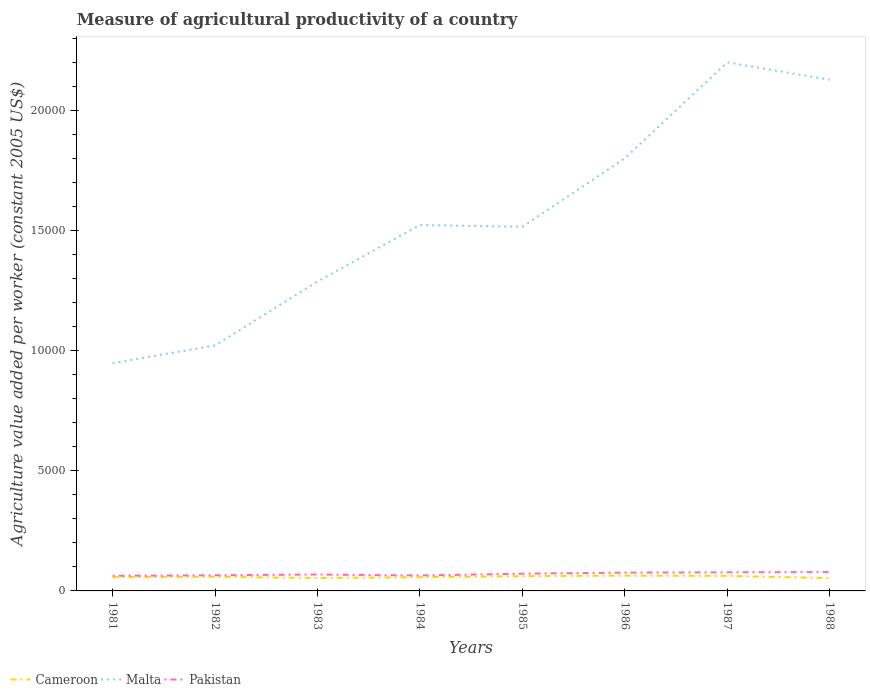How many different coloured lines are there?
Your response must be concise. 3. Across all years, what is the maximum measure of agricultural productivity in Cameroon?
Your response must be concise. 533.38. What is the total measure of agricultural productivity in Malta in the graph?
Provide a short and direct response. -3399.08. What is the difference between the highest and the second highest measure of agricultural productivity in Malta?
Offer a terse response. 1.25e+04. What is the difference between the highest and the lowest measure of agricultural productivity in Malta?
Your answer should be compact. 3. How many lines are there?
Give a very brief answer. 3. How many years are there in the graph?
Provide a succinct answer. 8. Are the values on the major ticks of Y-axis written in scientific E-notation?
Make the answer very short. No. What is the title of the graph?
Provide a succinct answer. Measure of agricultural productivity of a country. What is the label or title of the X-axis?
Provide a succinct answer. Years. What is the label or title of the Y-axis?
Your answer should be very brief. Agriculture value added per worker (constant 2005 US$). What is the Agriculture value added per worker (constant 2005 US$) in Cameroon in 1981?
Provide a succinct answer. 573.32. What is the Agriculture value added per worker (constant 2005 US$) in Malta in 1981?
Offer a very short reply. 9473.4. What is the Agriculture value added per worker (constant 2005 US$) in Pakistan in 1981?
Your answer should be compact. 629.36. What is the Agriculture value added per worker (constant 2005 US$) of Cameroon in 1982?
Your answer should be compact. 588.87. What is the Agriculture value added per worker (constant 2005 US$) of Malta in 1982?
Your response must be concise. 1.02e+04. What is the Agriculture value added per worker (constant 2005 US$) of Pakistan in 1982?
Your response must be concise. 649.18. What is the Agriculture value added per worker (constant 2005 US$) of Cameroon in 1983?
Give a very brief answer. 534.87. What is the Agriculture value added per worker (constant 2005 US$) in Malta in 1983?
Provide a short and direct response. 1.29e+04. What is the Agriculture value added per worker (constant 2005 US$) of Pakistan in 1983?
Ensure brevity in your answer.  682.93. What is the Agriculture value added per worker (constant 2005 US$) of Cameroon in 1984?
Offer a very short reply. 573.28. What is the Agriculture value added per worker (constant 2005 US$) in Malta in 1984?
Keep it short and to the point. 1.52e+04. What is the Agriculture value added per worker (constant 2005 US$) of Pakistan in 1984?
Offer a terse response. 641.81. What is the Agriculture value added per worker (constant 2005 US$) in Cameroon in 1985?
Your answer should be very brief. 613.52. What is the Agriculture value added per worker (constant 2005 US$) in Malta in 1985?
Provide a short and direct response. 1.51e+04. What is the Agriculture value added per worker (constant 2005 US$) in Pakistan in 1985?
Offer a terse response. 717.51. What is the Agriculture value added per worker (constant 2005 US$) in Cameroon in 1986?
Offer a very short reply. 636.09. What is the Agriculture value added per worker (constant 2005 US$) of Malta in 1986?
Provide a succinct answer. 1.80e+04. What is the Agriculture value added per worker (constant 2005 US$) of Pakistan in 1986?
Give a very brief answer. 761.5. What is the Agriculture value added per worker (constant 2005 US$) in Cameroon in 1987?
Your response must be concise. 624.71. What is the Agriculture value added per worker (constant 2005 US$) of Malta in 1987?
Keep it short and to the point. 2.20e+04. What is the Agriculture value added per worker (constant 2005 US$) in Pakistan in 1987?
Give a very brief answer. 773.63. What is the Agriculture value added per worker (constant 2005 US$) in Cameroon in 1988?
Give a very brief answer. 533.38. What is the Agriculture value added per worker (constant 2005 US$) in Malta in 1988?
Provide a short and direct response. 2.13e+04. What is the Agriculture value added per worker (constant 2005 US$) of Pakistan in 1988?
Your answer should be very brief. 782.91. Across all years, what is the maximum Agriculture value added per worker (constant 2005 US$) in Cameroon?
Give a very brief answer. 636.09. Across all years, what is the maximum Agriculture value added per worker (constant 2005 US$) in Malta?
Your response must be concise. 2.20e+04. Across all years, what is the maximum Agriculture value added per worker (constant 2005 US$) of Pakistan?
Ensure brevity in your answer.  782.91. Across all years, what is the minimum Agriculture value added per worker (constant 2005 US$) of Cameroon?
Give a very brief answer. 533.38. Across all years, what is the minimum Agriculture value added per worker (constant 2005 US$) of Malta?
Provide a short and direct response. 9473.4. Across all years, what is the minimum Agriculture value added per worker (constant 2005 US$) of Pakistan?
Your answer should be very brief. 629.36. What is the total Agriculture value added per worker (constant 2005 US$) in Cameroon in the graph?
Offer a terse response. 4678.05. What is the total Agriculture value added per worker (constant 2005 US$) of Malta in the graph?
Offer a terse response. 1.24e+05. What is the total Agriculture value added per worker (constant 2005 US$) in Pakistan in the graph?
Give a very brief answer. 5638.83. What is the difference between the Agriculture value added per worker (constant 2005 US$) of Cameroon in 1981 and that in 1982?
Keep it short and to the point. -15.55. What is the difference between the Agriculture value added per worker (constant 2005 US$) of Malta in 1981 and that in 1982?
Your answer should be compact. -737.77. What is the difference between the Agriculture value added per worker (constant 2005 US$) of Pakistan in 1981 and that in 1982?
Make the answer very short. -19.82. What is the difference between the Agriculture value added per worker (constant 2005 US$) in Cameroon in 1981 and that in 1983?
Ensure brevity in your answer.  38.45. What is the difference between the Agriculture value added per worker (constant 2005 US$) in Malta in 1981 and that in 1983?
Keep it short and to the point. -3399.08. What is the difference between the Agriculture value added per worker (constant 2005 US$) of Pakistan in 1981 and that in 1983?
Your answer should be very brief. -53.57. What is the difference between the Agriculture value added per worker (constant 2005 US$) in Cameroon in 1981 and that in 1984?
Give a very brief answer. 0.03. What is the difference between the Agriculture value added per worker (constant 2005 US$) in Malta in 1981 and that in 1984?
Provide a short and direct response. -5747.92. What is the difference between the Agriculture value added per worker (constant 2005 US$) in Pakistan in 1981 and that in 1984?
Keep it short and to the point. -12.45. What is the difference between the Agriculture value added per worker (constant 2005 US$) in Cameroon in 1981 and that in 1985?
Provide a short and direct response. -40.21. What is the difference between the Agriculture value added per worker (constant 2005 US$) in Malta in 1981 and that in 1985?
Make the answer very short. -5674.32. What is the difference between the Agriculture value added per worker (constant 2005 US$) in Pakistan in 1981 and that in 1985?
Offer a very short reply. -88.15. What is the difference between the Agriculture value added per worker (constant 2005 US$) in Cameroon in 1981 and that in 1986?
Give a very brief answer. -62.77. What is the difference between the Agriculture value added per worker (constant 2005 US$) in Malta in 1981 and that in 1986?
Make the answer very short. -8518.3. What is the difference between the Agriculture value added per worker (constant 2005 US$) in Pakistan in 1981 and that in 1986?
Ensure brevity in your answer.  -132.15. What is the difference between the Agriculture value added per worker (constant 2005 US$) of Cameroon in 1981 and that in 1987?
Your answer should be very brief. -51.39. What is the difference between the Agriculture value added per worker (constant 2005 US$) in Malta in 1981 and that in 1987?
Make the answer very short. -1.25e+04. What is the difference between the Agriculture value added per worker (constant 2005 US$) of Pakistan in 1981 and that in 1987?
Offer a terse response. -144.28. What is the difference between the Agriculture value added per worker (constant 2005 US$) in Cameroon in 1981 and that in 1988?
Your answer should be very brief. 39.94. What is the difference between the Agriculture value added per worker (constant 2005 US$) of Malta in 1981 and that in 1988?
Provide a succinct answer. -1.18e+04. What is the difference between the Agriculture value added per worker (constant 2005 US$) in Pakistan in 1981 and that in 1988?
Your answer should be compact. -153.56. What is the difference between the Agriculture value added per worker (constant 2005 US$) of Cameroon in 1982 and that in 1983?
Give a very brief answer. 54.01. What is the difference between the Agriculture value added per worker (constant 2005 US$) in Malta in 1982 and that in 1983?
Your answer should be very brief. -2661.31. What is the difference between the Agriculture value added per worker (constant 2005 US$) of Pakistan in 1982 and that in 1983?
Your answer should be very brief. -33.75. What is the difference between the Agriculture value added per worker (constant 2005 US$) in Cameroon in 1982 and that in 1984?
Keep it short and to the point. 15.59. What is the difference between the Agriculture value added per worker (constant 2005 US$) in Malta in 1982 and that in 1984?
Offer a very short reply. -5010.15. What is the difference between the Agriculture value added per worker (constant 2005 US$) in Pakistan in 1982 and that in 1984?
Your answer should be compact. 7.37. What is the difference between the Agriculture value added per worker (constant 2005 US$) of Cameroon in 1982 and that in 1985?
Your answer should be compact. -24.65. What is the difference between the Agriculture value added per worker (constant 2005 US$) in Malta in 1982 and that in 1985?
Offer a terse response. -4936.55. What is the difference between the Agriculture value added per worker (constant 2005 US$) in Pakistan in 1982 and that in 1985?
Give a very brief answer. -68.33. What is the difference between the Agriculture value added per worker (constant 2005 US$) in Cameroon in 1982 and that in 1986?
Your answer should be very brief. -47.22. What is the difference between the Agriculture value added per worker (constant 2005 US$) in Malta in 1982 and that in 1986?
Provide a short and direct response. -7780.53. What is the difference between the Agriculture value added per worker (constant 2005 US$) of Pakistan in 1982 and that in 1986?
Ensure brevity in your answer.  -112.33. What is the difference between the Agriculture value added per worker (constant 2005 US$) in Cameroon in 1982 and that in 1987?
Give a very brief answer. -35.83. What is the difference between the Agriculture value added per worker (constant 2005 US$) of Malta in 1982 and that in 1987?
Give a very brief answer. -1.18e+04. What is the difference between the Agriculture value added per worker (constant 2005 US$) in Pakistan in 1982 and that in 1987?
Make the answer very short. -124.46. What is the difference between the Agriculture value added per worker (constant 2005 US$) in Cameroon in 1982 and that in 1988?
Offer a terse response. 55.49. What is the difference between the Agriculture value added per worker (constant 2005 US$) in Malta in 1982 and that in 1988?
Keep it short and to the point. -1.11e+04. What is the difference between the Agriculture value added per worker (constant 2005 US$) of Pakistan in 1982 and that in 1988?
Provide a short and direct response. -133.74. What is the difference between the Agriculture value added per worker (constant 2005 US$) of Cameroon in 1983 and that in 1984?
Provide a succinct answer. -38.42. What is the difference between the Agriculture value added per worker (constant 2005 US$) of Malta in 1983 and that in 1984?
Keep it short and to the point. -2348.84. What is the difference between the Agriculture value added per worker (constant 2005 US$) in Pakistan in 1983 and that in 1984?
Ensure brevity in your answer.  41.12. What is the difference between the Agriculture value added per worker (constant 2005 US$) of Cameroon in 1983 and that in 1985?
Give a very brief answer. -78.66. What is the difference between the Agriculture value added per worker (constant 2005 US$) of Malta in 1983 and that in 1985?
Provide a succinct answer. -2275.24. What is the difference between the Agriculture value added per worker (constant 2005 US$) in Pakistan in 1983 and that in 1985?
Keep it short and to the point. -34.58. What is the difference between the Agriculture value added per worker (constant 2005 US$) in Cameroon in 1983 and that in 1986?
Your answer should be very brief. -101.22. What is the difference between the Agriculture value added per worker (constant 2005 US$) of Malta in 1983 and that in 1986?
Your answer should be very brief. -5119.22. What is the difference between the Agriculture value added per worker (constant 2005 US$) of Pakistan in 1983 and that in 1986?
Ensure brevity in your answer.  -78.58. What is the difference between the Agriculture value added per worker (constant 2005 US$) in Cameroon in 1983 and that in 1987?
Provide a short and direct response. -89.84. What is the difference between the Agriculture value added per worker (constant 2005 US$) of Malta in 1983 and that in 1987?
Offer a very short reply. -9114.55. What is the difference between the Agriculture value added per worker (constant 2005 US$) of Pakistan in 1983 and that in 1987?
Give a very brief answer. -90.71. What is the difference between the Agriculture value added per worker (constant 2005 US$) in Cameroon in 1983 and that in 1988?
Give a very brief answer. 1.48. What is the difference between the Agriculture value added per worker (constant 2005 US$) of Malta in 1983 and that in 1988?
Keep it short and to the point. -8389.81. What is the difference between the Agriculture value added per worker (constant 2005 US$) in Pakistan in 1983 and that in 1988?
Provide a succinct answer. -99.99. What is the difference between the Agriculture value added per worker (constant 2005 US$) in Cameroon in 1984 and that in 1985?
Provide a short and direct response. -40.24. What is the difference between the Agriculture value added per worker (constant 2005 US$) of Malta in 1984 and that in 1985?
Your answer should be very brief. 73.6. What is the difference between the Agriculture value added per worker (constant 2005 US$) in Pakistan in 1984 and that in 1985?
Give a very brief answer. -75.7. What is the difference between the Agriculture value added per worker (constant 2005 US$) of Cameroon in 1984 and that in 1986?
Offer a terse response. -62.81. What is the difference between the Agriculture value added per worker (constant 2005 US$) of Malta in 1984 and that in 1986?
Offer a very short reply. -2770.38. What is the difference between the Agriculture value added per worker (constant 2005 US$) in Pakistan in 1984 and that in 1986?
Provide a succinct answer. -119.69. What is the difference between the Agriculture value added per worker (constant 2005 US$) of Cameroon in 1984 and that in 1987?
Make the answer very short. -51.42. What is the difference between the Agriculture value added per worker (constant 2005 US$) of Malta in 1984 and that in 1987?
Provide a short and direct response. -6765.71. What is the difference between the Agriculture value added per worker (constant 2005 US$) in Pakistan in 1984 and that in 1987?
Your response must be concise. -131.82. What is the difference between the Agriculture value added per worker (constant 2005 US$) of Cameroon in 1984 and that in 1988?
Provide a succinct answer. 39.9. What is the difference between the Agriculture value added per worker (constant 2005 US$) in Malta in 1984 and that in 1988?
Make the answer very short. -6040.97. What is the difference between the Agriculture value added per worker (constant 2005 US$) in Pakistan in 1984 and that in 1988?
Keep it short and to the point. -141.11. What is the difference between the Agriculture value added per worker (constant 2005 US$) of Cameroon in 1985 and that in 1986?
Give a very brief answer. -22.57. What is the difference between the Agriculture value added per worker (constant 2005 US$) in Malta in 1985 and that in 1986?
Provide a short and direct response. -2843.98. What is the difference between the Agriculture value added per worker (constant 2005 US$) in Pakistan in 1985 and that in 1986?
Provide a short and direct response. -43.99. What is the difference between the Agriculture value added per worker (constant 2005 US$) of Cameroon in 1985 and that in 1987?
Keep it short and to the point. -11.18. What is the difference between the Agriculture value added per worker (constant 2005 US$) in Malta in 1985 and that in 1987?
Provide a succinct answer. -6839.31. What is the difference between the Agriculture value added per worker (constant 2005 US$) in Pakistan in 1985 and that in 1987?
Your answer should be compact. -56.12. What is the difference between the Agriculture value added per worker (constant 2005 US$) of Cameroon in 1985 and that in 1988?
Your response must be concise. 80.14. What is the difference between the Agriculture value added per worker (constant 2005 US$) of Malta in 1985 and that in 1988?
Your answer should be compact. -6114.57. What is the difference between the Agriculture value added per worker (constant 2005 US$) in Pakistan in 1985 and that in 1988?
Give a very brief answer. -65.4. What is the difference between the Agriculture value added per worker (constant 2005 US$) of Cameroon in 1986 and that in 1987?
Offer a terse response. 11.38. What is the difference between the Agriculture value added per worker (constant 2005 US$) of Malta in 1986 and that in 1987?
Offer a terse response. -3995.34. What is the difference between the Agriculture value added per worker (constant 2005 US$) in Pakistan in 1986 and that in 1987?
Your answer should be compact. -12.13. What is the difference between the Agriculture value added per worker (constant 2005 US$) of Cameroon in 1986 and that in 1988?
Offer a terse response. 102.71. What is the difference between the Agriculture value added per worker (constant 2005 US$) of Malta in 1986 and that in 1988?
Make the answer very short. -3270.59. What is the difference between the Agriculture value added per worker (constant 2005 US$) of Pakistan in 1986 and that in 1988?
Offer a terse response. -21.41. What is the difference between the Agriculture value added per worker (constant 2005 US$) in Cameroon in 1987 and that in 1988?
Ensure brevity in your answer.  91.32. What is the difference between the Agriculture value added per worker (constant 2005 US$) of Malta in 1987 and that in 1988?
Provide a short and direct response. 724.74. What is the difference between the Agriculture value added per worker (constant 2005 US$) of Pakistan in 1987 and that in 1988?
Give a very brief answer. -9.28. What is the difference between the Agriculture value added per worker (constant 2005 US$) in Cameroon in 1981 and the Agriculture value added per worker (constant 2005 US$) in Malta in 1982?
Make the answer very short. -9637.85. What is the difference between the Agriculture value added per worker (constant 2005 US$) in Cameroon in 1981 and the Agriculture value added per worker (constant 2005 US$) in Pakistan in 1982?
Provide a succinct answer. -75.86. What is the difference between the Agriculture value added per worker (constant 2005 US$) of Malta in 1981 and the Agriculture value added per worker (constant 2005 US$) of Pakistan in 1982?
Your response must be concise. 8824.22. What is the difference between the Agriculture value added per worker (constant 2005 US$) in Cameroon in 1981 and the Agriculture value added per worker (constant 2005 US$) in Malta in 1983?
Make the answer very short. -1.23e+04. What is the difference between the Agriculture value added per worker (constant 2005 US$) of Cameroon in 1981 and the Agriculture value added per worker (constant 2005 US$) of Pakistan in 1983?
Your answer should be compact. -109.61. What is the difference between the Agriculture value added per worker (constant 2005 US$) of Malta in 1981 and the Agriculture value added per worker (constant 2005 US$) of Pakistan in 1983?
Ensure brevity in your answer.  8790.47. What is the difference between the Agriculture value added per worker (constant 2005 US$) in Cameroon in 1981 and the Agriculture value added per worker (constant 2005 US$) in Malta in 1984?
Provide a succinct answer. -1.46e+04. What is the difference between the Agriculture value added per worker (constant 2005 US$) in Cameroon in 1981 and the Agriculture value added per worker (constant 2005 US$) in Pakistan in 1984?
Make the answer very short. -68.49. What is the difference between the Agriculture value added per worker (constant 2005 US$) in Malta in 1981 and the Agriculture value added per worker (constant 2005 US$) in Pakistan in 1984?
Offer a terse response. 8831.59. What is the difference between the Agriculture value added per worker (constant 2005 US$) in Cameroon in 1981 and the Agriculture value added per worker (constant 2005 US$) in Malta in 1985?
Keep it short and to the point. -1.46e+04. What is the difference between the Agriculture value added per worker (constant 2005 US$) of Cameroon in 1981 and the Agriculture value added per worker (constant 2005 US$) of Pakistan in 1985?
Keep it short and to the point. -144.19. What is the difference between the Agriculture value added per worker (constant 2005 US$) of Malta in 1981 and the Agriculture value added per worker (constant 2005 US$) of Pakistan in 1985?
Give a very brief answer. 8755.89. What is the difference between the Agriculture value added per worker (constant 2005 US$) of Cameroon in 1981 and the Agriculture value added per worker (constant 2005 US$) of Malta in 1986?
Offer a very short reply. -1.74e+04. What is the difference between the Agriculture value added per worker (constant 2005 US$) of Cameroon in 1981 and the Agriculture value added per worker (constant 2005 US$) of Pakistan in 1986?
Your response must be concise. -188.18. What is the difference between the Agriculture value added per worker (constant 2005 US$) of Malta in 1981 and the Agriculture value added per worker (constant 2005 US$) of Pakistan in 1986?
Your answer should be very brief. 8711.89. What is the difference between the Agriculture value added per worker (constant 2005 US$) of Cameroon in 1981 and the Agriculture value added per worker (constant 2005 US$) of Malta in 1987?
Your response must be concise. -2.14e+04. What is the difference between the Agriculture value added per worker (constant 2005 US$) in Cameroon in 1981 and the Agriculture value added per worker (constant 2005 US$) in Pakistan in 1987?
Your answer should be very brief. -200.31. What is the difference between the Agriculture value added per worker (constant 2005 US$) in Malta in 1981 and the Agriculture value added per worker (constant 2005 US$) in Pakistan in 1987?
Offer a very short reply. 8699.77. What is the difference between the Agriculture value added per worker (constant 2005 US$) of Cameroon in 1981 and the Agriculture value added per worker (constant 2005 US$) of Malta in 1988?
Provide a succinct answer. -2.07e+04. What is the difference between the Agriculture value added per worker (constant 2005 US$) in Cameroon in 1981 and the Agriculture value added per worker (constant 2005 US$) in Pakistan in 1988?
Keep it short and to the point. -209.59. What is the difference between the Agriculture value added per worker (constant 2005 US$) in Malta in 1981 and the Agriculture value added per worker (constant 2005 US$) in Pakistan in 1988?
Make the answer very short. 8690.48. What is the difference between the Agriculture value added per worker (constant 2005 US$) of Cameroon in 1982 and the Agriculture value added per worker (constant 2005 US$) of Malta in 1983?
Your response must be concise. -1.23e+04. What is the difference between the Agriculture value added per worker (constant 2005 US$) in Cameroon in 1982 and the Agriculture value added per worker (constant 2005 US$) in Pakistan in 1983?
Ensure brevity in your answer.  -94.05. What is the difference between the Agriculture value added per worker (constant 2005 US$) of Malta in 1982 and the Agriculture value added per worker (constant 2005 US$) of Pakistan in 1983?
Offer a terse response. 9528.24. What is the difference between the Agriculture value added per worker (constant 2005 US$) of Cameroon in 1982 and the Agriculture value added per worker (constant 2005 US$) of Malta in 1984?
Offer a very short reply. -1.46e+04. What is the difference between the Agriculture value added per worker (constant 2005 US$) of Cameroon in 1982 and the Agriculture value added per worker (constant 2005 US$) of Pakistan in 1984?
Ensure brevity in your answer.  -52.94. What is the difference between the Agriculture value added per worker (constant 2005 US$) of Malta in 1982 and the Agriculture value added per worker (constant 2005 US$) of Pakistan in 1984?
Provide a succinct answer. 9569.36. What is the difference between the Agriculture value added per worker (constant 2005 US$) in Cameroon in 1982 and the Agriculture value added per worker (constant 2005 US$) in Malta in 1985?
Give a very brief answer. -1.46e+04. What is the difference between the Agriculture value added per worker (constant 2005 US$) of Cameroon in 1982 and the Agriculture value added per worker (constant 2005 US$) of Pakistan in 1985?
Offer a terse response. -128.64. What is the difference between the Agriculture value added per worker (constant 2005 US$) of Malta in 1982 and the Agriculture value added per worker (constant 2005 US$) of Pakistan in 1985?
Your answer should be compact. 9493.66. What is the difference between the Agriculture value added per worker (constant 2005 US$) of Cameroon in 1982 and the Agriculture value added per worker (constant 2005 US$) of Malta in 1986?
Keep it short and to the point. -1.74e+04. What is the difference between the Agriculture value added per worker (constant 2005 US$) in Cameroon in 1982 and the Agriculture value added per worker (constant 2005 US$) in Pakistan in 1986?
Your response must be concise. -172.63. What is the difference between the Agriculture value added per worker (constant 2005 US$) in Malta in 1982 and the Agriculture value added per worker (constant 2005 US$) in Pakistan in 1986?
Give a very brief answer. 9449.66. What is the difference between the Agriculture value added per worker (constant 2005 US$) of Cameroon in 1982 and the Agriculture value added per worker (constant 2005 US$) of Malta in 1987?
Your answer should be compact. -2.14e+04. What is the difference between the Agriculture value added per worker (constant 2005 US$) in Cameroon in 1982 and the Agriculture value added per worker (constant 2005 US$) in Pakistan in 1987?
Offer a terse response. -184.76. What is the difference between the Agriculture value added per worker (constant 2005 US$) of Malta in 1982 and the Agriculture value added per worker (constant 2005 US$) of Pakistan in 1987?
Offer a terse response. 9437.53. What is the difference between the Agriculture value added per worker (constant 2005 US$) in Cameroon in 1982 and the Agriculture value added per worker (constant 2005 US$) in Malta in 1988?
Ensure brevity in your answer.  -2.07e+04. What is the difference between the Agriculture value added per worker (constant 2005 US$) in Cameroon in 1982 and the Agriculture value added per worker (constant 2005 US$) in Pakistan in 1988?
Offer a terse response. -194.04. What is the difference between the Agriculture value added per worker (constant 2005 US$) of Malta in 1982 and the Agriculture value added per worker (constant 2005 US$) of Pakistan in 1988?
Provide a short and direct response. 9428.25. What is the difference between the Agriculture value added per worker (constant 2005 US$) of Cameroon in 1983 and the Agriculture value added per worker (constant 2005 US$) of Malta in 1984?
Make the answer very short. -1.47e+04. What is the difference between the Agriculture value added per worker (constant 2005 US$) in Cameroon in 1983 and the Agriculture value added per worker (constant 2005 US$) in Pakistan in 1984?
Provide a short and direct response. -106.94. What is the difference between the Agriculture value added per worker (constant 2005 US$) of Malta in 1983 and the Agriculture value added per worker (constant 2005 US$) of Pakistan in 1984?
Your response must be concise. 1.22e+04. What is the difference between the Agriculture value added per worker (constant 2005 US$) of Cameroon in 1983 and the Agriculture value added per worker (constant 2005 US$) of Malta in 1985?
Make the answer very short. -1.46e+04. What is the difference between the Agriculture value added per worker (constant 2005 US$) of Cameroon in 1983 and the Agriculture value added per worker (constant 2005 US$) of Pakistan in 1985?
Provide a short and direct response. -182.64. What is the difference between the Agriculture value added per worker (constant 2005 US$) in Malta in 1983 and the Agriculture value added per worker (constant 2005 US$) in Pakistan in 1985?
Make the answer very short. 1.22e+04. What is the difference between the Agriculture value added per worker (constant 2005 US$) of Cameroon in 1983 and the Agriculture value added per worker (constant 2005 US$) of Malta in 1986?
Your response must be concise. -1.75e+04. What is the difference between the Agriculture value added per worker (constant 2005 US$) in Cameroon in 1983 and the Agriculture value added per worker (constant 2005 US$) in Pakistan in 1986?
Make the answer very short. -226.64. What is the difference between the Agriculture value added per worker (constant 2005 US$) in Malta in 1983 and the Agriculture value added per worker (constant 2005 US$) in Pakistan in 1986?
Offer a very short reply. 1.21e+04. What is the difference between the Agriculture value added per worker (constant 2005 US$) in Cameroon in 1983 and the Agriculture value added per worker (constant 2005 US$) in Malta in 1987?
Offer a very short reply. -2.15e+04. What is the difference between the Agriculture value added per worker (constant 2005 US$) of Cameroon in 1983 and the Agriculture value added per worker (constant 2005 US$) of Pakistan in 1987?
Offer a very short reply. -238.77. What is the difference between the Agriculture value added per worker (constant 2005 US$) of Malta in 1983 and the Agriculture value added per worker (constant 2005 US$) of Pakistan in 1987?
Make the answer very short. 1.21e+04. What is the difference between the Agriculture value added per worker (constant 2005 US$) of Cameroon in 1983 and the Agriculture value added per worker (constant 2005 US$) of Malta in 1988?
Your response must be concise. -2.07e+04. What is the difference between the Agriculture value added per worker (constant 2005 US$) of Cameroon in 1983 and the Agriculture value added per worker (constant 2005 US$) of Pakistan in 1988?
Offer a very short reply. -248.05. What is the difference between the Agriculture value added per worker (constant 2005 US$) of Malta in 1983 and the Agriculture value added per worker (constant 2005 US$) of Pakistan in 1988?
Make the answer very short. 1.21e+04. What is the difference between the Agriculture value added per worker (constant 2005 US$) of Cameroon in 1984 and the Agriculture value added per worker (constant 2005 US$) of Malta in 1985?
Make the answer very short. -1.46e+04. What is the difference between the Agriculture value added per worker (constant 2005 US$) of Cameroon in 1984 and the Agriculture value added per worker (constant 2005 US$) of Pakistan in 1985?
Offer a very short reply. -144.23. What is the difference between the Agriculture value added per worker (constant 2005 US$) in Malta in 1984 and the Agriculture value added per worker (constant 2005 US$) in Pakistan in 1985?
Offer a very short reply. 1.45e+04. What is the difference between the Agriculture value added per worker (constant 2005 US$) of Cameroon in 1984 and the Agriculture value added per worker (constant 2005 US$) of Malta in 1986?
Keep it short and to the point. -1.74e+04. What is the difference between the Agriculture value added per worker (constant 2005 US$) of Cameroon in 1984 and the Agriculture value added per worker (constant 2005 US$) of Pakistan in 1986?
Your response must be concise. -188.22. What is the difference between the Agriculture value added per worker (constant 2005 US$) in Malta in 1984 and the Agriculture value added per worker (constant 2005 US$) in Pakistan in 1986?
Keep it short and to the point. 1.45e+04. What is the difference between the Agriculture value added per worker (constant 2005 US$) of Cameroon in 1984 and the Agriculture value added per worker (constant 2005 US$) of Malta in 1987?
Your response must be concise. -2.14e+04. What is the difference between the Agriculture value added per worker (constant 2005 US$) in Cameroon in 1984 and the Agriculture value added per worker (constant 2005 US$) in Pakistan in 1987?
Give a very brief answer. -200.35. What is the difference between the Agriculture value added per worker (constant 2005 US$) of Malta in 1984 and the Agriculture value added per worker (constant 2005 US$) of Pakistan in 1987?
Your response must be concise. 1.44e+04. What is the difference between the Agriculture value added per worker (constant 2005 US$) in Cameroon in 1984 and the Agriculture value added per worker (constant 2005 US$) in Malta in 1988?
Give a very brief answer. -2.07e+04. What is the difference between the Agriculture value added per worker (constant 2005 US$) in Cameroon in 1984 and the Agriculture value added per worker (constant 2005 US$) in Pakistan in 1988?
Provide a short and direct response. -209.63. What is the difference between the Agriculture value added per worker (constant 2005 US$) of Malta in 1984 and the Agriculture value added per worker (constant 2005 US$) of Pakistan in 1988?
Make the answer very short. 1.44e+04. What is the difference between the Agriculture value added per worker (constant 2005 US$) in Cameroon in 1985 and the Agriculture value added per worker (constant 2005 US$) in Malta in 1986?
Your answer should be very brief. -1.74e+04. What is the difference between the Agriculture value added per worker (constant 2005 US$) in Cameroon in 1985 and the Agriculture value added per worker (constant 2005 US$) in Pakistan in 1986?
Give a very brief answer. -147.98. What is the difference between the Agriculture value added per worker (constant 2005 US$) in Malta in 1985 and the Agriculture value added per worker (constant 2005 US$) in Pakistan in 1986?
Offer a terse response. 1.44e+04. What is the difference between the Agriculture value added per worker (constant 2005 US$) of Cameroon in 1985 and the Agriculture value added per worker (constant 2005 US$) of Malta in 1987?
Your answer should be very brief. -2.14e+04. What is the difference between the Agriculture value added per worker (constant 2005 US$) of Cameroon in 1985 and the Agriculture value added per worker (constant 2005 US$) of Pakistan in 1987?
Ensure brevity in your answer.  -160.11. What is the difference between the Agriculture value added per worker (constant 2005 US$) in Malta in 1985 and the Agriculture value added per worker (constant 2005 US$) in Pakistan in 1987?
Make the answer very short. 1.44e+04. What is the difference between the Agriculture value added per worker (constant 2005 US$) of Cameroon in 1985 and the Agriculture value added per worker (constant 2005 US$) of Malta in 1988?
Your answer should be compact. -2.06e+04. What is the difference between the Agriculture value added per worker (constant 2005 US$) of Cameroon in 1985 and the Agriculture value added per worker (constant 2005 US$) of Pakistan in 1988?
Your response must be concise. -169.39. What is the difference between the Agriculture value added per worker (constant 2005 US$) of Malta in 1985 and the Agriculture value added per worker (constant 2005 US$) of Pakistan in 1988?
Your answer should be very brief. 1.44e+04. What is the difference between the Agriculture value added per worker (constant 2005 US$) in Cameroon in 1986 and the Agriculture value added per worker (constant 2005 US$) in Malta in 1987?
Your answer should be very brief. -2.14e+04. What is the difference between the Agriculture value added per worker (constant 2005 US$) in Cameroon in 1986 and the Agriculture value added per worker (constant 2005 US$) in Pakistan in 1987?
Ensure brevity in your answer.  -137.54. What is the difference between the Agriculture value added per worker (constant 2005 US$) of Malta in 1986 and the Agriculture value added per worker (constant 2005 US$) of Pakistan in 1987?
Your answer should be very brief. 1.72e+04. What is the difference between the Agriculture value added per worker (constant 2005 US$) of Cameroon in 1986 and the Agriculture value added per worker (constant 2005 US$) of Malta in 1988?
Give a very brief answer. -2.06e+04. What is the difference between the Agriculture value added per worker (constant 2005 US$) in Cameroon in 1986 and the Agriculture value added per worker (constant 2005 US$) in Pakistan in 1988?
Give a very brief answer. -146.82. What is the difference between the Agriculture value added per worker (constant 2005 US$) in Malta in 1986 and the Agriculture value added per worker (constant 2005 US$) in Pakistan in 1988?
Ensure brevity in your answer.  1.72e+04. What is the difference between the Agriculture value added per worker (constant 2005 US$) of Cameroon in 1987 and the Agriculture value added per worker (constant 2005 US$) of Malta in 1988?
Ensure brevity in your answer.  -2.06e+04. What is the difference between the Agriculture value added per worker (constant 2005 US$) in Cameroon in 1987 and the Agriculture value added per worker (constant 2005 US$) in Pakistan in 1988?
Keep it short and to the point. -158.21. What is the difference between the Agriculture value added per worker (constant 2005 US$) of Malta in 1987 and the Agriculture value added per worker (constant 2005 US$) of Pakistan in 1988?
Offer a very short reply. 2.12e+04. What is the average Agriculture value added per worker (constant 2005 US$) of Cameroon per year?
Give a very brief answer. 584.76. What is the average Agriculture value added per worker (constant 2005 US$) in Malta per year?
Offer a terse response. 1.55e+04. What is the average Agriculture value added per worker (constant 2005 US$) in Pakistan per year?
Ensure brevity in your answer.  704.85. In the year 1981, what is the difference between the Agriculture value added per worker (constant 2005 US$) in Cameroon and Agriculture value added per worker (constant 2005 US$) in Malta?
Give a very brief answer. -8900.08. In the year 1981, what is the difference between the Agriculture value added per worker (constant 2005 US$) of Cameroon and Agriculture value added per worker (constant 2005 US$) of Pakistan?
Ensure brevity in your answer.  -56.04. In the year 1981, what is the difference between the Agriculture value added per worker (constant 2005 US$) in Malta and Agriculture value added per worker (constant 2005 US$) in Pakistan?
Ensure brevity in your answer.  8844.04. In the year 1982, what is the difference between the Agriculture value added per worker (constant 2005 US$) in Cameroon and Agriculture value added per worker (constant 2005 US$) in Malta?
Offer a very short reply. -9622.29. In the year 1982, what is the difference between the Agriculture value added per worker (constant 2005 US$) of Cameroon and Agriculture value added per worker (constant 2005 US$) of Pakistan?
Make the answer very short. -60.3. In the year 1982, what is the difference between the Agriculture value added per worker (constant 2005 US$) of Malta and Agriculture value added per worker (constant 2005 US$) of Pakistan?
Your answer should be compact. 9561.99. In the year 1983, what is the difference between the Agriculture value added per worker (constant 2005 US$) of Cameroon and Agriculture value added per worker (constant 2005 US$) of Malta?
Make the answer very short. -1.23e+04. In the year 1983, what is the difference between the Agriculture value added per worker (constant 2005 US$) of Cameroon and Agriculture value added per worker (constant 2005 US$) of Pakistan?
Your answer should be compact. -148.06. In the year 1983, what is the difference between the Agriculture value added per worker (constant 2005 US$) of Malta and Agriculture value added per worker (constant 2005 US$) of Pakistan?
Offer a very short reply. 1.22e+04. In the year 1984, what is the difference between the Agriculture value added per worker (constant 2005 US$) in Cameroon and Agriculture value added per worker (constant 2005 US$) in Malta?
Provide a short and direct response. -1.46e+04. In the year 1984, what is the difference between the Agriculture value added per worker (constant 2005 US$) of Cameroon and Agriculture value added per worker (constant 2005 US$) of Pakistan?
Give a very brief answer. -68.52. In the year 1984, what is the difference between the Agriculture value added per worker (constant 2005 US$) in Malta and Agriculture value added per worker (constant 2005 US$) in Pakistan?
Keep it short and to the point. 1.46e+04. In the year 1985, what is the difference between the Agriculture value added per worker (constant 2005 US$) of Cameroon and Agriculture value added per worker (constant 2005 US$) of Malta?
Your response must be concise. -1.45e+04. In the year 1985, what is the difference between the Agriculture value added per worker (constant 2005 US$) of Cameroon and Agriculture value added per worker (constant 2005 US$) of Pakistan?
Keep it short and to the point. -103.98. In the year 1985, what is the difference between the Agriculture value added per worker (constant 2005 US$) of Malta and Agriculture value added per worker (constant 2005 US$) of Pakistan?
Ensure brevity in your answer.  1.44e+04. In the year 1986, what is the difference between the Agriculture value added per worker (constant 2005 US$) of Cameroon and Agriculture value added per worker (constant 2005 US$) of Malta?
Offer a very short reply. -1.74e+04. In the year 1986, what is the difference between the Agriculture value added per worker (constant 2005 US$) of Cameroon and Agriculture value added per worker (constant 2005 US$) of Pakistan?
Keep it short and to the point. -125.41. In the year 1986, what is the difference between the Agriculture value added per worker (constant 2005 US$) in Malta and Agriculture value added per worker (constant 2005 US$) in Pakistan?
Provide a short and direct response. 1.72e+04. In the year 1987, what is the difference between the Agriculture value added per worker (constant 2005 US$) in Cameroon and Agriculture value added per worker (constant 2005 US$) in Malta?
Your response must be concise. -2.14e+04. In the year 1987, what is the difference between the Agriculture value added per worker (constant 2005 US$) in Cameroon and Agriculture value added per worker (constant 2005 US$) in Pakistan?
Offer a very short reply. -148.93. In the year 1987, what is the difference between the Agriculture value added per worker (constant 2005 US$) in Malta and Agriculture value added per worker (constant 2005 US$) in Pakistan?
Keep it short and to the point. 2.12e+04. In the year 1988, what is the difference between the Agriculture value added per worker (constant 2005 US$) of Cameroon and Agriculture value added per worker (constant 2005 US$) of Malta?
Provide a succinct answer. -2.07e+04. In the year 1988, what is the difference between the Agriculture value added per worker (constant 2005 US$) of Cameroon and Agriculture value added per worker (constant 2005 US$) of Pakistan?
Give a very brief answer. -249.53. In the year 1988, what is the difference between the Agriculture value added per worker (constant 2005 US$) in Malta and Agriculture value added per worker (constant 2005 US$) in Pakistan?
Keep it short and to the point. 2.05e+04. What is the ratio of the Agriculture value added per worker (constant 2005 US$) of Cameroon in 1981 to that in 1982?
Provide a succinct answer. 0.97. What is the ratio of the Agriculture value added per worker (constant 2005 US$) of Malta in 1981 to that in 1982?
Your answer should be very brief. 0.93. What is the ratio of the Agriculture value added per worker (constant 2005 US$) of Pakistan in 1981 to that in 1982?
Offer a very short reply. 0.97. What is the ratio of the Agriculture value added per worker (constant 2005 US$) in Cameroon in 1981 to that in 1983?
Your answer should be compact. 1.07. What is the ratio of the Agriculture value added per worker (constant 2005 US$) of Malta in 1981 to that in 1983?
Give a very brief answer. 0.74. What is the ratio of the Agriculture value added per worker (constant 2005 US$) of Pakistan in 1981 to that in 1983?
Your answer should be very brief. 0.92. What is the ratio of the Agriculture value added per worker (constant 2005 US$) of Malta in 1981 to that in 1984?
Provide a short and direct response. 0.62. What is the ratio of the Agriculture value added per worker (constant 2005 US$) of Pakistan in 1981 to that in 1984?
Offer a very short reply. 0.98. What is the ratio of the Agriculture value added per worker (constant 2005 US$) of Cameroon in 1981 to that in 1985?
Ensure brevity in your answer.  0.93. What is the ratio of the Agriculture value added per worker (constant 2005 US$) of Malta in 1981 to that in 1985?
Keep it short and to the point. 0.63. What is the ratio of the Agriculture value added per worker (constant 2005 US$) of Pakistan in 1981 to that in 1985?
Make the answer very short. 0.88. What is the ratio of the Agriculture value added per worker (constant 2005 US$) in Cameroon in 1981 to that in 1986?
Keep it short and to the point. 0.9. What is the ratio of the Agriculture value added per worker (constant 2005 US$) in Malta in 1981 to that in 1986?
Provide a succinct answer. 0.53. What is the ratio of the Agriculture value added per worker (constant 2005 US$) in Pakistan in 1981 to that in 1986?
Provide a succinct answer. 0.83. What is the ratio of the Agriculture value added per worker (constant 2005 US$) in Cameroon in 1981 to that in 1987?
Your response must be concise. 0.92. What is the ratio of the Agriculture value added per worker (constant 2005 US$) in Malta in 1981 to that in 1987?
Your answer should be compact. 0.43. What is the ratio of the Agriculture value added per worker (constant 2005 US$) of Pakistan in 1981 to that in 1987?
Your answer should be compact. 0.81. What is the ratio of the Agriculture value added per worker (constant 2005 US$) of Cameroon in 1981 to that in 1988?
Make the answer very short. 1.07. What is the ratio of the Agriculture value added per worker (constant 2005 US$) of Malta in 1981 to that in 1988?
Your answer should be compact. 0.45. What is the ratio of the Agriculture value added per worker (constant 2005 US$) in Pakistan in 1981 to that in 1988?
Your answer should be compact. 0.8. What is the ratio of the Agriculture value added per worker (constant 2005 US$) of Cameroon in 1982 to that in 1983?
Provide a succinct answer. 1.1. What is the ratio of the Agriculture value added per worker (constant 2005 US$) in Malta in 1982 to that in 1983?
Give a very brief answer. 0.79. What is the ratio of the Agriculture value added per worker (constant 2005 US$) in Pakistan in 1982 to that in 1983?
Your answer should be compact. 0.95. What is the ratio of the Agriculture value added per worker (constant 2005 US$) in Cameroon in 1982 to that in 1984?
Offer a terse response. 1.03. What is the ratio of the Agriculture value added per worker (constant 2005 US$) in Malta in 1982 to that in 1984?
Your answer should be very brief. 0.67. What is the ratio of the Agriculture value added per worker (constant 2005 US$) of Pakistan in 1982 to that in 1984?
Your response must be concise. 1.01. What is the ratio of the Agriculture value added per worker (constant 2005 US$) of Cameroon in 1982 to that in 1985?
Make the answer very short. 0.96. What is the ratio of the Agriculture value added per worker (constant 2005 US$) of Malta in 1982 to that in 1985?
Provide a succinct answer. 0.67. What is the ratio of the Agriculture value added per worker (constant 2005 US$) of Pakistan in 1982 to that in 1985?
Provide a succinct answer. 0.9. What is the ratio of the Agriculture value added per worker (constant 2005 US$) of Cameroon in 1982 to that in 1986?
Give a very brief answer. 0.93. What is the ratio of the Agriculture value added per worker (constant 2005 US$) of Malta in 1982 to that in 1986?
Provide a short and direct response. 0.57. What is the ratio of the Agriculture value added per worker (constant 2005 US$) in Pakistan in 1982 to that in 1986?
Keep it short and to the point. 0.85. What is the ratio of the Agriculture value added per worker (constant 2005 US$) in Cameroon in 1982 to that in 1987?
Give a very brief answer. 0.94. What is the ratio of the Agriculture value added per worker (constant 2005 US$) of Malta in 1982 to that in 1987?
Your answer should be compact. 0.46. What is the ratio of the Agriculture value added per worker (constant 2005 US$) in Pakistan in 1982 to that in 1987?
Ensure brevity in your answer.  0.84. What is the ratio of the Agriculture value added per worker (constant 2005 US$) of Cameroon in 1982 to that in 1988?
Provide a succinct answer. 1.1. What is the ratio of the Agriculture value added per worker (constant 2005 US$) of Malta in 1982 to that in 1988?
Offer a terse response. 0.48. What is the ratio of the Agriculture value added per worker (constant 2005 US$) in Pakistan in 1982 to that in 1988?
Your answer should be compact. 0.83. What is the ratio of the Agriculture value added per worker (constant 2005 US$) of Cameroon in 1983 to that in 1984?
Provide a succinct answer. 0.93. What is the ratio of the Agriculture value added per worker (constant 2005 US$) of Malta in 1983 to that in 1984?
Your response must be concise. 0.85. What is the ratio of the Agriculture value added per worker (constant 2005 US$) of Pakistan in 1983 to that in 1984?
Your response must be concise. 1.06. What is the ratio of the Agriculture value added per worker (constant 2005 US$) in Cameroon in 1983 to that in 1985?
Your answer should be compact. 0.87. What is the ratio of the Agriculture value added per worker (constant 2005 US$) in Malta in 1983 to that in 1985?
Your answer should be compact. 0.85. What is the ratio of the Agriculture value added per worker (constant 2005 US$) in Pakistan in 1983 to that in 1985?
Offer a terse response. 0.95. What is the ratio of the Agriculture value added per worker (constant 2005 US$) in Cameroon in 1983 to that in 1986?
Provide a succinct answer. 0.84. What is the ratio of the Agriculture value added per worker (constant 2005 US$) of Malta in 1983 to that in 1986?
Provide a succinct answer. 0.72. What is the ratio of the Agriculture value added per worker (constant 2005 US$) of Pakistan in 1983 to that in 1986?
Your response must be concise. 0.9. What is the ratio of the Agriculture value added per worker (constant 2005 US$) of Cameroon in 1983 to that in 1987?
Keep it short and to the point. 0.86. What is the ratio of the Agriculture value added per worker (constant 2005 US$) of Malta in 1983 to that in 1987?
Offer a very short reply. 0.59. What is the ratio of the Agriculture value added per worker (constant 2005 US$) of Pakistan in 1983 to that in 1987?
Keep it short and to the point. 0.88. What is the ratio of the Agriculture value added per worker (constant 2005 US$) of Malta in 1983 to that in 1988?
Offer a terse response. 0.61. What is the ratio of the Agriculture value added per worker (constant 2005 US$) of Pakistan in 1983 to that in 1988?
Provide a short and direct response. 0.87. What is the ratio of the Agriculture value added per worker (constant 2005 US$) of Cameroon in 1984 to that in 1985?
Ensure brevity in your answer.  0.93. What is the ratio of the Agriculture value added per worker (constant 2005 US$) in Malta in 1984 to that in 1985?
Offer a terse response. 1. What is the ratio of the Agriculture value added per worker (constant 2005 US$) of Pakistan in 1984 to that in 1985?
Ensure brevity in your answer.  0.89. What is the ratio of the Agriculture value added per worker (constant 2005 US$) in Cameroon in 1984 to that in 1986?
Your answer should be compact. 0.9. What is the ratio of the Agriculture value added per worker (constant 2005 US$) of Malta in 1984 to that in 1986?
Give a very brief answer. 0.85. What is the ratio of the Agriculture value added per worker (constant 2005 US$) in Pakistan in 1984 to that in 1986?
Offer a very short reply. 0.84. What is the ratio of the Agriculture value added per worker (constant 2005 US$) in Cameroon in 1984 to that in 1987?
Offer a very short reply. 0.92. What is the ratio of the Agriculture value added per worker (constant 2005 US$) of Malta in 1984 to that in 1987?
Give a very brief answer. 0.69. What is the ratio of the Agriculture value added per worker (constant 2005 US$) of Pakistan in 1984 to that in 1987?
Provide a short and direct response. 0.83. What is the ratio of the Agriculture value added per worker (constant 2005 US$) of Cameroon in 1984 to that in 1988?
Your response must be concise. 1.07. What is the ratio of the Agriculture value added per worker (constant 2005 US$) of Malta in 1984 to that in 1988?
Provide a succinct answer. 0.72. What is the ratio of the Agriculture value added per worker (constant 2005 US$) of Pakistan in 1984 to that in 1988?
Offer a very short reply. 0.82. What is the ratio of the Agriculture value added per worker (constant 2005 US$) of Cameroon in 1985 to that in 1986?
Ensure brevity in your answer.  0.96. What is the ratio of the Agriculture value added per worker (constant 2005 US$) in Malta in 1985 to that in 1986?
Give a very brief answer. 0.84. What is the ratio of the Agriculture value added per worker (constant 2005 US$) of Pakistan in 1985 to that in 1986?
Ensure brevity in your answer.  0.94. What is the ratio of the Agriculture value added per worker (constant 2005 US$) of Cameroon in 1985 to that in 1987?
Offer a very short reply. 0.98. What is the ratio of the Agriculture value added per worker (constant 2005 US$) of Malta in 1985 to that in 1987?
Make the answer very short. 0.69. What is the ratio of the Agriculture value added per worker (constant 2005 US$) of Pakistan in 1985 to that in 1987?
Provide a succinct answer. 0.93. What is the ratio of the Agriculture value added per worker (constant 2005 US$) in Cameroon in 1985 to that in 1988?
Provide a short and direct response. 1.15. What is the ratio of the Agriculture value added per worker (constant 2005 US$) in Malta in 1985 to that in 1988?
Offer a terse response. 0.71. What is the ratio of the Agriculture value added per worker (constant 2005 US$) of Pakistan in 1985 to that in 1988?
Your response must be concise. 0.92. What is the ratio of the Agriculture value added per worker (constant 2005 US$) in Cameroon in 1986 to that in 1987?
Make the answer very short. 1.02. What is the ratio of the Agriculture value added per worker (constant 2005 US$) in Malta in 1986 to that in 1987?
Offer a very short reply. 0.82. What is the ratio of the Agriculture value added per worker (constant 2005 US$) of Pakistan in 1986 to that in 1987?
Ensure brevity in your answer.  0.98. What is the ratio of the Agriculture value added per worker (constant 2005 US$) of Cameroon in 1986 to that in 1988?
Ensure brevity in your answer.  1.19. What is the ratio of the Agriculture value added per worker (constant 2005 US$) of Malta in 1986 to that in 1988?
Keep it short and to the point. 0.85. What is the ratio of the Agriculture value added per worker (constant 2005 US$) in Pakistan in 1986 to that in 1988?
Provide a succinct answer. 0.97. What is the ratio of the Agriculture value added per worker (constant 2005 US$) of Cameroon in 1987 to that in 1988?
Give a very brief answer. 1.17. What is the ratio of the Agriculture value added per worker (constant 2005 US$) in Malta in 1987 to that in 1988?
Ensure brevity in your answer.  1.03. What is the difference between the highest and the second highest Agriculture value added per worker (constant 2005 US$) of Cameroon?
Your response must be concise. 11.38. What is the difference between the highest and the second highest Agriculture value added per worker (constant 2005 US$) of Malta?
Make the answer very short. 724.74. What is the difference between the highest and the second highest Agriculture value added per worker (constant 2005 US$) in Pakistan?
Offer a terse response. 9.28. What is the difference between the highest and the lowest Agriculture value added per worker (constant 2005 US$) of Cameroon?
Make the answer very short. 102.71. What is the difference between the highest and the lowest Agriculture value added per worker (constant 2005 US$) of Malta?
Your answer should be compact. 1.25e+04. What is the difference between the highest and the lowest Agriculture value added per worker (constant 2005 US$) of Pakistan?
Make the answer very short. 153.56. 